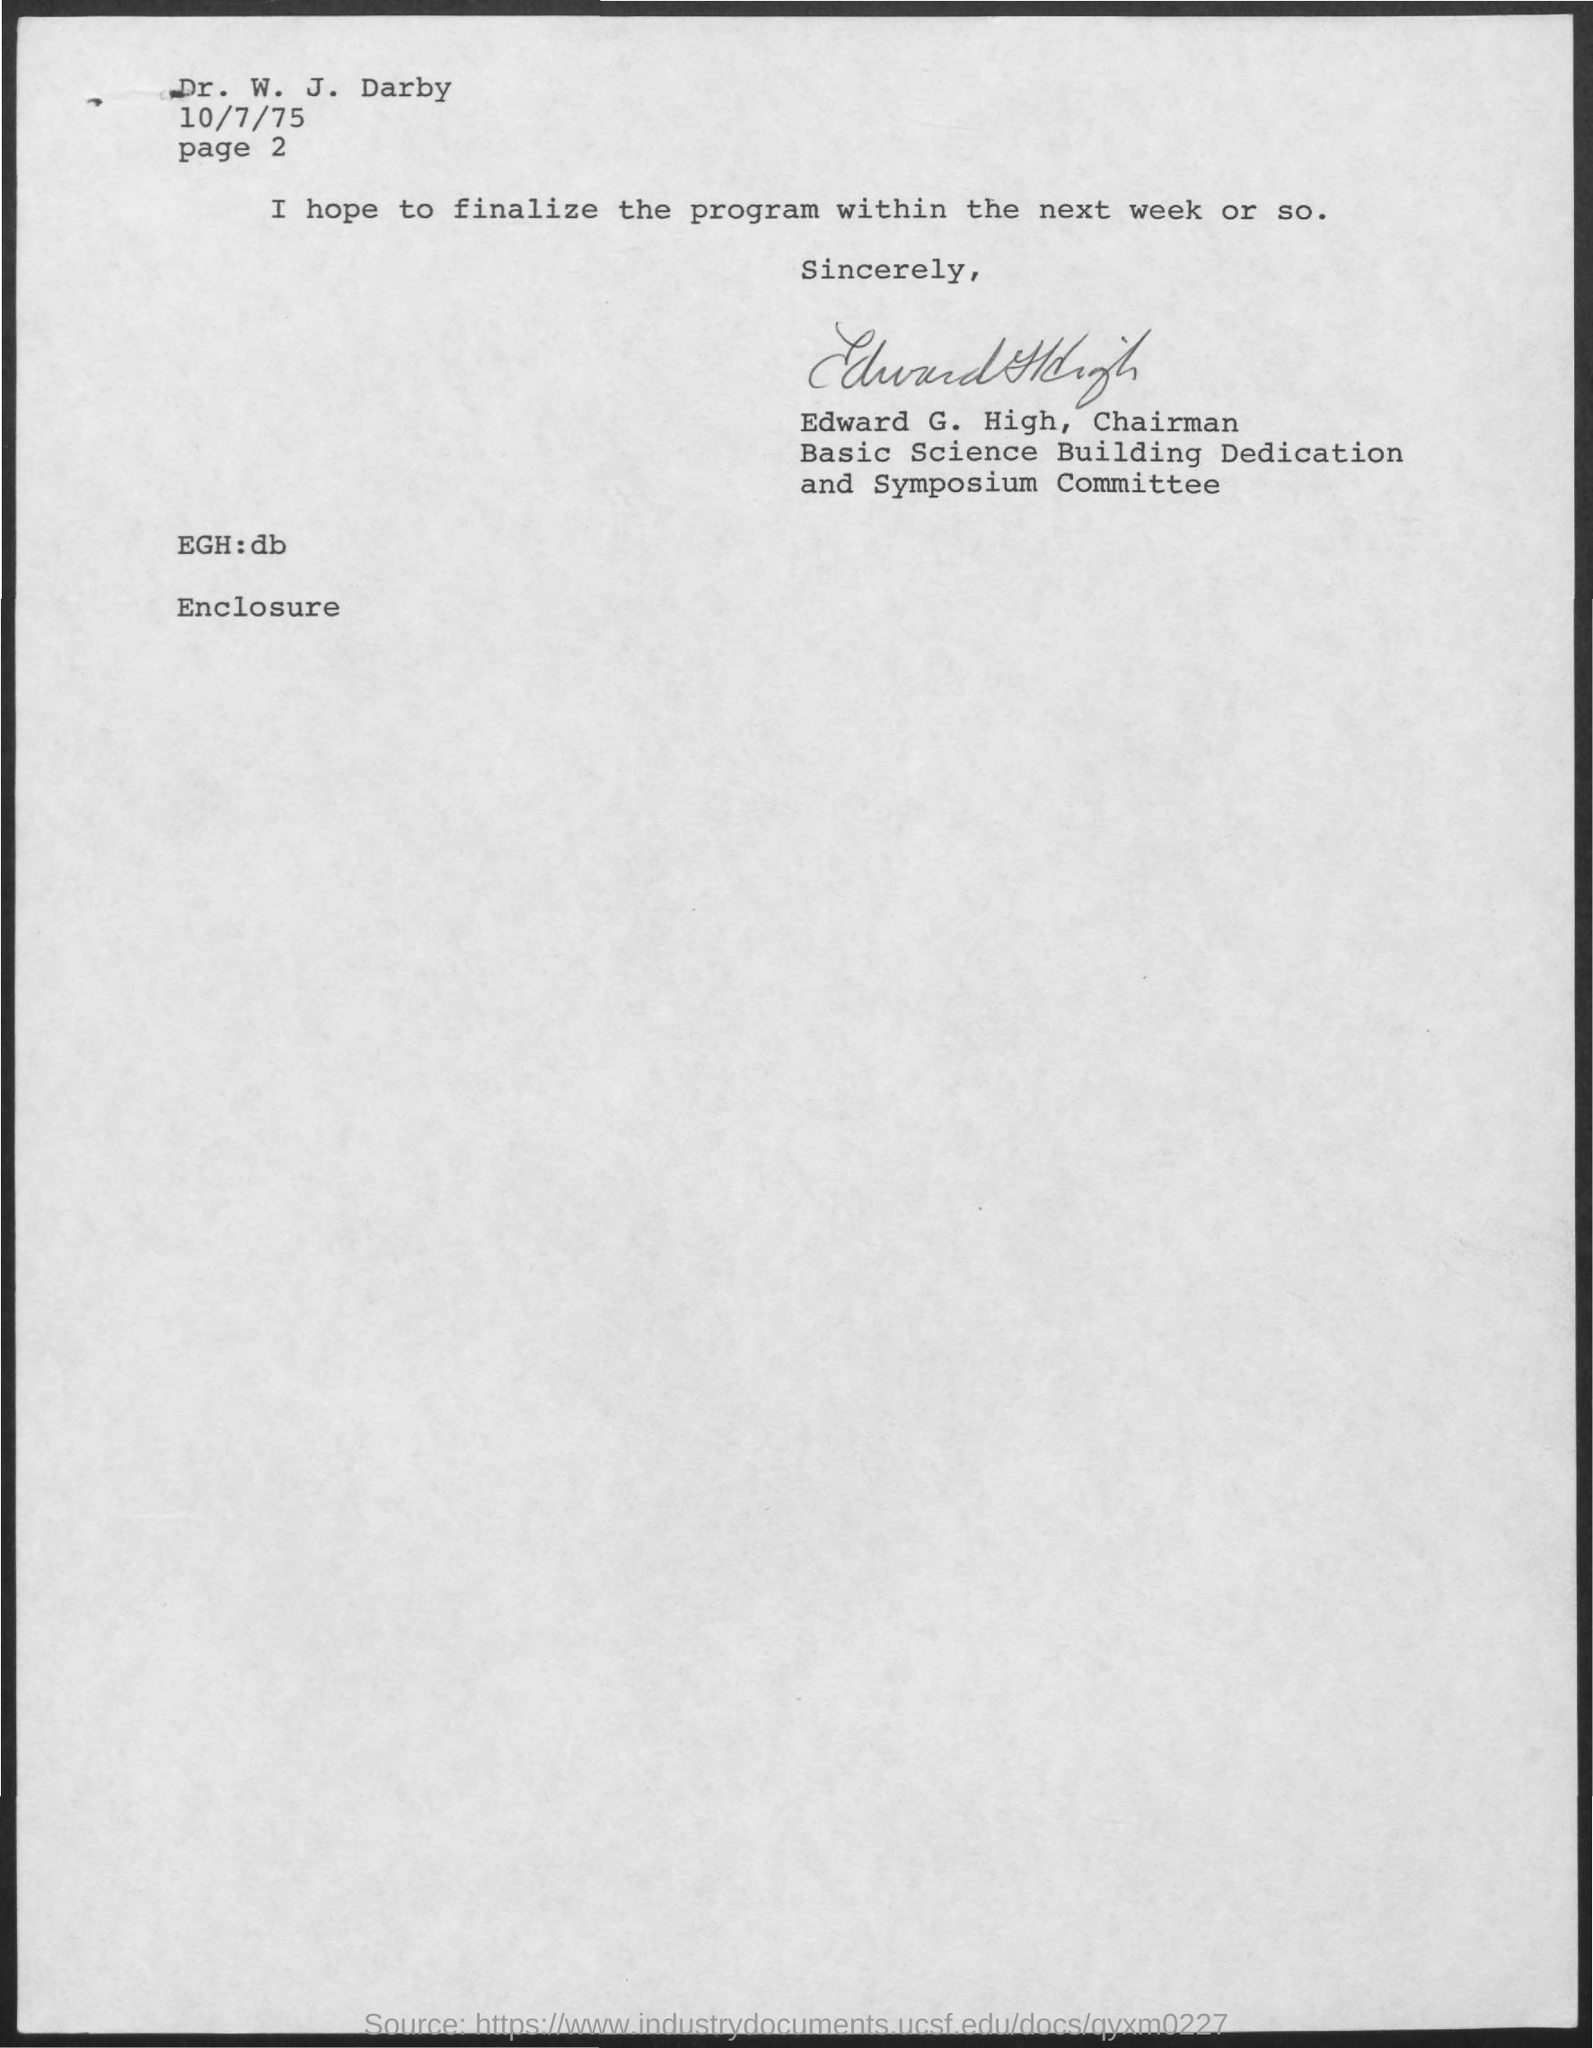Outline some significant characteristics in this image. The issued date of this letter is 10/7/75, as declared in the text. The addressee of this letter is Dr. W. J. Darby. 